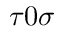<formula> <loc_0><loc_0><loc_500><loc_500>\tau 0 \sigma</formula> 